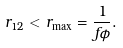<formula> <loc_0><loc_0><loc_500><loc_500>r _ { 1 2 } < r _ { \max } = \frac { 1 } { f \phi } .</formula> 